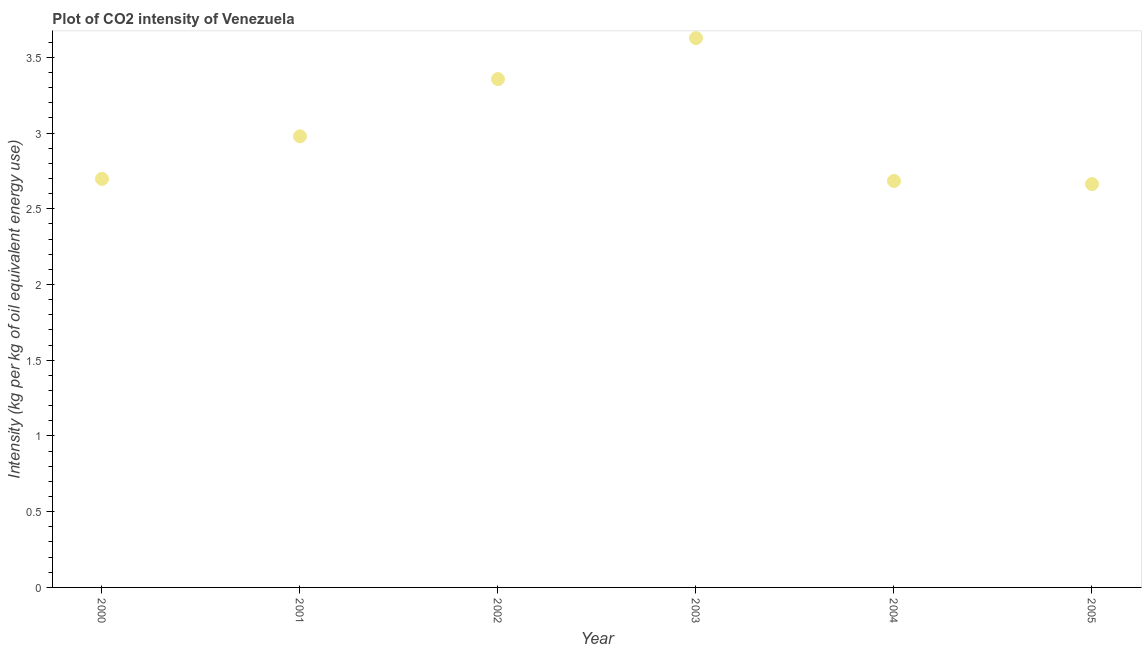What is the co2 intensity in 2004?
Provide a succinct answer. 2.68. Across all years, what is the maximum co2 intensity?
Your answer should be compact. 3.63. Across all years, what is the minimum co2 intensity?
Your answer should be very brief. 2.66. What is the sum of the co2 intensity?
Provide a succinct answer. 18.01. What is the difference between the co2 intensity in 2002 and 2004?
Offer a terse response. 0.67. What is the average co2 intensity per year?
Your answer should be very brief. 3. What is the median co2 intensity?
Provide a succinct answer. 2.84. What is the ratio of the co2 intensity in 2004 to that in 2005?
Your answer should be very brief. 1.01. What is the difference between the highest and the second highest co2 intensity?
Make the answer very short. 0.27. Is the sum of the co2 intensity in 2000 and 2003 greater than the maximum co2 intensity across all years?
Ensure brevity in your answer.  Yes. What is the difference between the highest and the lowest co2 intensity?
Provide a short and direct response. 0.96. How many years are there in the graph?
Offer a very short reply. 6. What is the difference between two consecutive major ticks on the Y-axis?
Make the answer very short. 0.5. Are the values on the major ticks of Y-axis written in scientific E-notation?
Offer a very short reply. No. Does the graph contain any zero values?
Give a very brief answer. No. What is the title of the graph?
Offer a terse response. Plot of CO2 intensity of Venezuela. What is the label or title of the X-axis?
Your answer should be compact. Year. What is the label or title of the Y-axis?
Offer a very short reply. Intensity (kg per kg of oil equivalent energy use). What is the Intensity (kg per kg of oil equivalent energy use) in 2000?
Provide a short and direct response. 2.7. What is the Intensity (kg per kg of oil equivalent energy use) in 2001?
Your answer should be compact. 2.98. What is the Intensity (kg per kg of oil equivalent energy use) in 2002?
Offer a very short reply. 3.36. What is the Intensity (kg per kg of oil equivalent energy use) in 2003?
Your answer should be very brief. 3.63. What is the Intensity (kg per kg of oil equivalent energy use) in 2004?
Make the answer very short. 2.68. What is the Intensity (kg per kg of oil equivalent energy use) in 2005?
Make the answer very short. 2.66. What is the difference between the Intensity (kg per kg of oil equivalent energy use) in 2000 and 2001?
Provide a short and direct response. -0.28. What is the difference between the Intensity (kg per kg of oil equivalent energy use) in 2000 and 2002?
Give a very brief answer. -0.66. What is the difference between the Intensity (kg per kg of oil equivalent energy use) in 2000 and 2003?
Provide a succinct answer. -0.93. What is the difference between the Intensity (kg per kg of oil equivalent energy use) in 2000 and 2004?
Your answer should be compact. 0.01. What is the difference between the Intensity (kg per kg of oil equivalent energy use) in 2000 and 2005?
Your response must be concise. 0.03. What is the difference between the Intensity (kg per kg of oil equivalent energy use) in 2001 and 2002?
Make the answer very short. -0.38. What is the difference between the Intensity (kg per kg of oil equivalent energy use) in 2001 and 2003?
Your answer should be compact. -0.65. What is the difference between the Intensity (kg per kg of oil equivalent energy use) in 2001 and 2004?
Your response must be concise. 0.29. What is the difference between the Intensity (kg per kg of oil equivalent energy use) in 2001 and 2005?
Your answer should be compact. 0.32. What is the difference between the Intensity (kg per kg of oil equivalent energy use) in 2002 and 2003?
Provide a short and direct response. -0.27. What is the difference between the Intensity (kg per kg of oil equivalent energy use) in 2002 and 2004?
Offer a very short reply. 0.67. What is the difference between the Intensity (kg per kg of oil equivalent energy use) in 2002 and 2005?
Your response must be concise. 0.69. What is the difference between the Intensity (kg per kg of oil equivalent energy use) in 2003 and 2004?
Provide a short and direct response. 0.94. What is the difference between the Intensity (kg per kg of oil equivalent energy use) in 2003 and 2005?
Offer a terse response. 0.96. What is the difference between the Intensity (kg per kg of oil equivalent energy use) in 2004 and 2005?
Make the answer very short. 0.02. What is the ratio of the Intensity (kg per kg of oil equivalent energy use) in 2000 to that in 2001?
Your answer should be very brief. 0.91. What is the ratio of the Intensity (kg per kg of oil equivalent energy use) in 2000 to that in 2002?
Keep it short and to the point. 0.8. What is the ratio of the Intensity (kg per kg of oil equivalent energy use) in 2000 to that in 2003?
Ensure brevity in your answer.  0.74. What is the ratio of the Intensity (kg per kg of oil equivalent energy use) in 2000 to that in 2005?
Give a very brief answer. 1.01. What is the ratio of the Intensity (kg per kg of oil equivalent energy use) in 2001 to that in 2002?
Offer a very short reply. 0.89. What is the ratio of the Intensity (kg per kg of oil equivalent energy use) in 2001 to that in 2003?
Offer a very short reply. 0.82. What is the ratio of the Intensity (kg per kg of oil equivalent energy use) in 2001 to that in 2004?
Keep it short and to the point. 1.11. What is the ratio of the Intensity (kg per kg of oil equivalent energy use) in 2001 to that in 2005?
Offer a terse response. 1.12. What is the ratio of the Intensity (kg per kg of oil equivalent energy use) in 2002 to that in 2003?
Provide a short and direct response. 0.93. What is the ratio of the Intensity (kg per kg of oil equivalent energy use) in 2002 to that in 2004?
Provide a succinct answer. 1.25. What is the ratio of the Intensity (kg per kg of oil equivalent energy use) in 2002 to that in 2005?
Ensure brevity in your answer.  1.26. What is the ratio of the Intensity (kg per kg of oil equivalent energy use) in 2003 to that in 2004?
Your answer should be very brief. 1.35. What is the ratio of the Intensity (kg per kg of oil equivalent energy use) in 2003 to that in 2005?
Provide a succinct answer. 1.36. What is the ratio of the Intensity (kg per kg of oil equivalent energy use) in 2004 to that in 2005?
Offer a very short reply. 1.01. 